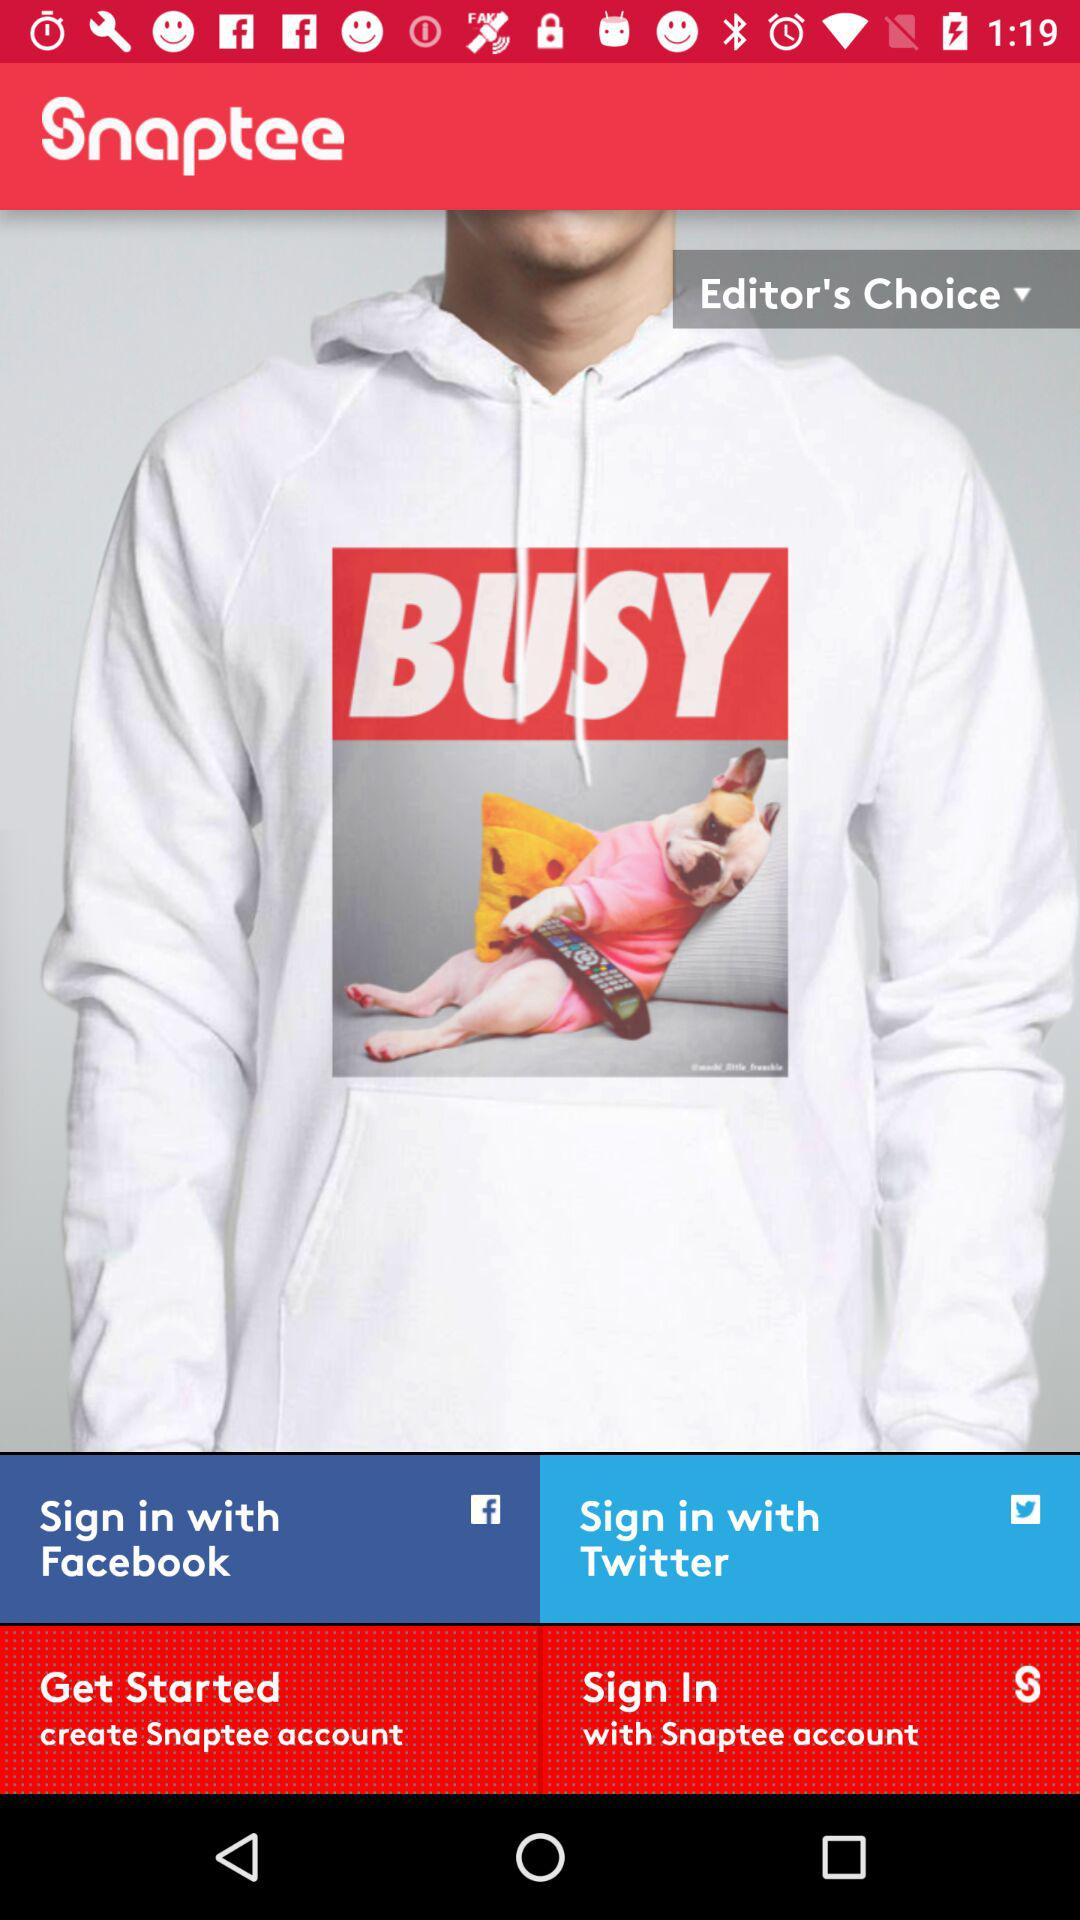How much does "Snaptee" cost?
When the provided information is insufficient, respond with <no answer>. <no answer> 